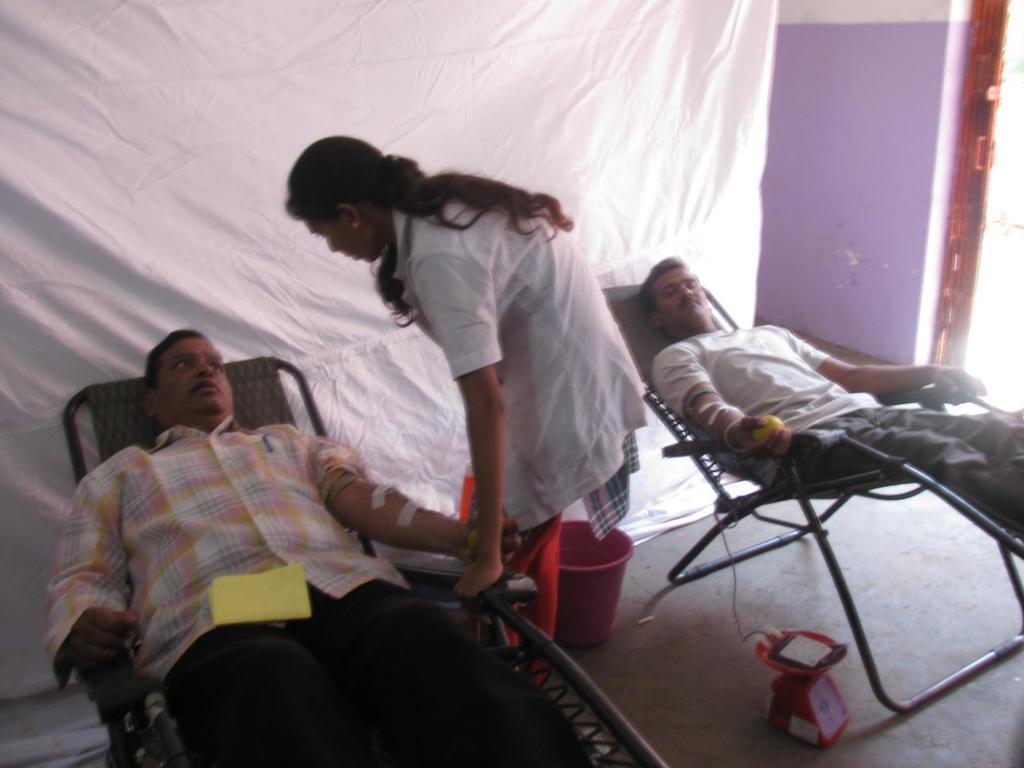In one or two sentences, can you explain what this image depicts? In this picture, There are two person sitting on the chairs and in the middle there is a girl standing and she is holding the chair, There is a bucket which is in red color, In the background there is a white color curtain in the right side there is a wall and there is a grill in brown color. 